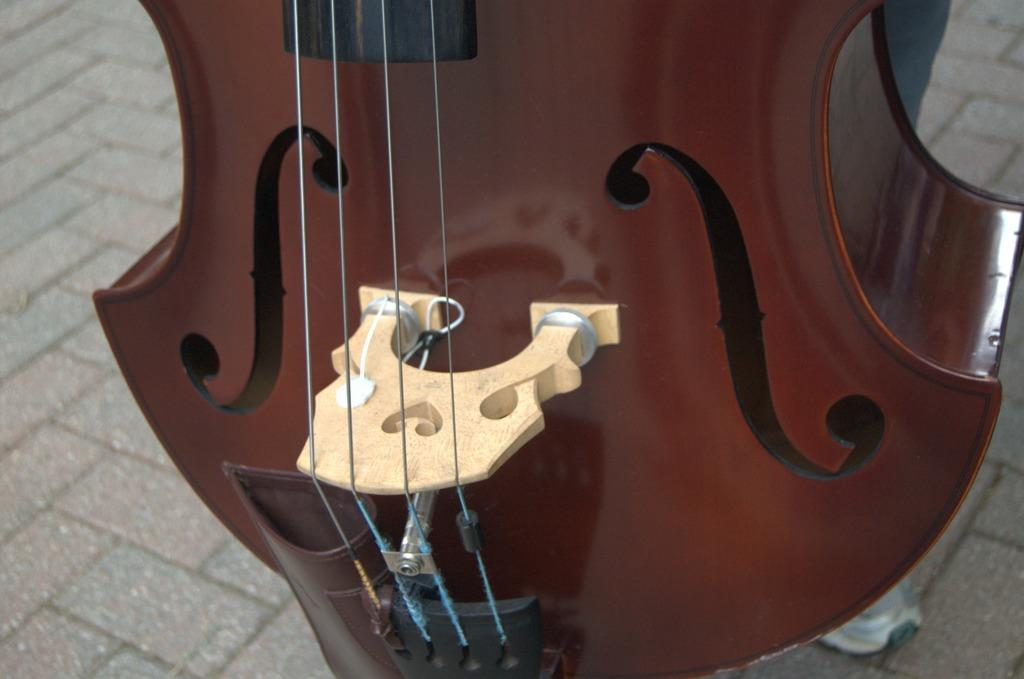What type of musical instrument is in the image? There is a brown color violin in the image. How is the violin described? The violin is described as beautiful. Can you tell me anything about the person in the background of the image? There is a person in the background of the image, but no specific details are provided. What type of scientific experiment is being conducted with the spoon in the image? There is no spoon present in the image, and therefore no scientific experiment can be observed. What type of canvas is the person in the background painting on? There is no canvas or painting activity mentioned in the image. 